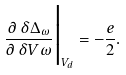<formula> <loc_0><loc_0><loc_500><loc_500>\frac { \partial \, \delta \Delta _ { \omega } } { \partial \, \delta V \omega } \Big | _ { V _ { d } } = - \frac { e } { 2 } .</formula> 